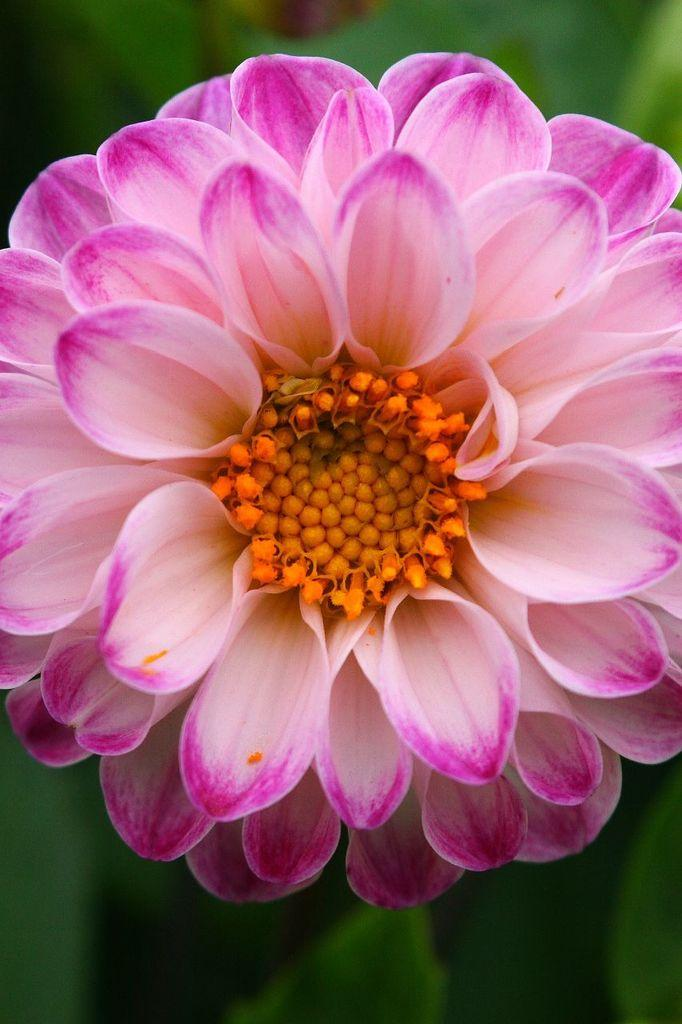What is the main subject of the image? There is a flower in the image. What color is the background of the image? The background of the image is green. How steep is the hill in the image? There is no hill present in the image; it features a flower and a green background. What type of beast can be seen interacting with the flower in the image? There is no beast present in the image; only the flower and the green background are visible. 